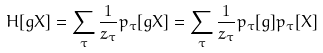<formula> <loc_0><loc_0><loc_500><loc_500>H [ g X ] & = \sum _ { \tau } \frac { 1 } { z _ { \tau } } p _ { \tau } [ g X ] = \sum _ { \tau } \frac { 1 } { z _ { \tau } } p _ { \tau } [ g ] p _ { \tau } [ X ]</formula> 